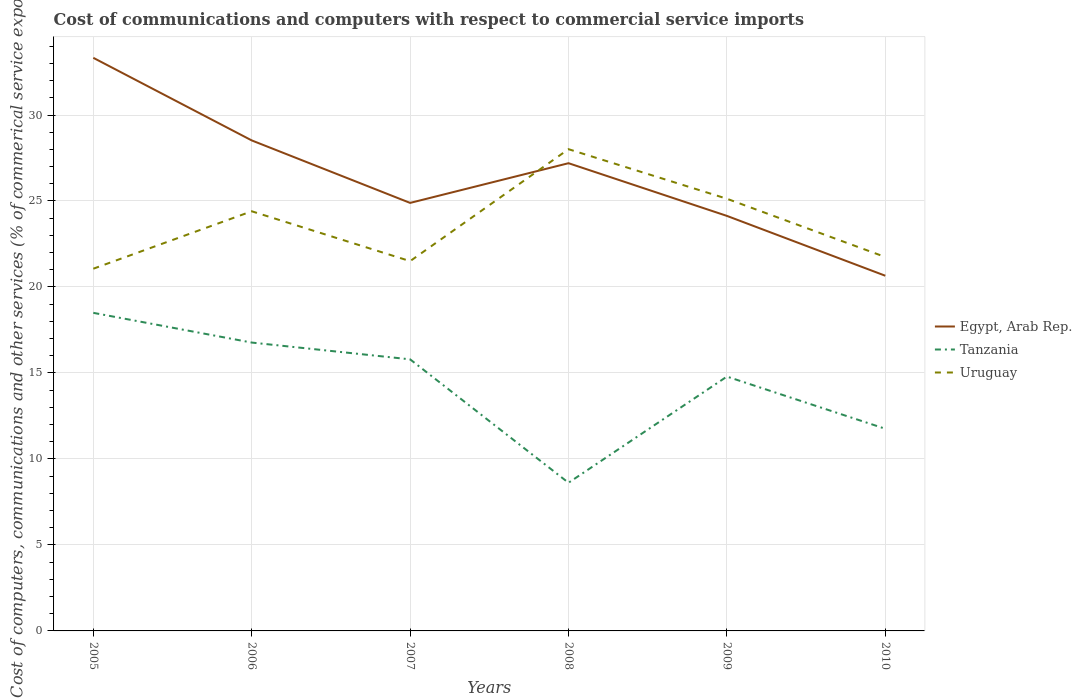How many different coloured lines are there?
Provide a short and direct response. 3. Does the line corresponding to Egypt, Arab Rep. intersect with the line corresponding to Uruguay?
Keep it short and to the point. Yes. Is the number of lines equal to the number of legend labels?
Offer a terse response. Yes. Across all years, what is the maximum cost of communications and computers in Tanzania?
Your answer should be very brief. 8.62. In which year was the cost of communications and computers in Egypt, Arab Rep. maximum?
Your answer should be very brief. 2010. What is the total cost of communications and computers in Tanzania in the graph?
Make the answer very short. 3.04. What is the difference between the highest and the second highest cost of communications and computers in Tanzania?
Offer a terse response. 9.88. What is the difference between the highest and the lowest cost of communications and computers in Egypt, Arab Rep.?
Your answer should be very brief. 3. Is the cost of communications and computers in Egypt, Arab Rep. strictly greater than the cost of communications and computers in Uruguay over the years?
Provide a succinct answer. No. Are the values on the major ticks of Y-axis written in scientific E-notation?
Keep it short and to the point. No. Does the graph contain any zero values?
Your response must be concise. No. How many legend labels are there?
Your response must be concise. 3. What is the title of the graph?
Your answer should be compact. Cost of communications and computers with respect to commercial service imports. What is the label or title of the Y-axis?
Keep it short and to the point. Cost of computers, communications and other services (% of commerical service exports). What is the Cost of computers, communications and other services (% of commerical service exports) in Egypt, Arab Rep. in 2005?
Give a very brief answer. 33.33. What is the Cost of computers, communications and other services (% of commerical service exports) of Tanzania in 2005?
Give a very brief answer. 18.5. What is the Cost of computers, communications and other services (% of commerical service exports) in Uruguay in 2005?
Offer a terse response. 21.06. What is the Cost of computers, communications and other services (% of commerical service exports) of Egypt, Arab Rep. in 2006?
Your answer should be compact. 28.52. What is the Cost of computers, communications and other services (% of commerical service exports) in Tanzania in 2006?
Keep it short and to the point. 16.77. What is the Cost of computers, communications and other services (% of commerical service exports) in Uruguay in 2006?
Keep it short and to the point. 24.4. What is the Cost of computers, communications and other services (% of commerical service exports) in Egypt, Arab Rep. in 2007?
Your answer should be compact. 24.89. What is the Cost of computers, communications and other services (% of commerical service exports) in Tanzania in 2007?
Ensure brevity in your answer.  15.79. What is the Cost of computers, communications and other services (% of commerical service exports) in Uruguay in 2007?
Offer a terse response. 21.5. What is the Cost of computers, communications and other services (% of commerical service exports) in Egypt, Arab Rep. in 2008?
Make the answer very short. 27.2. What is the Cost of computers, communications and other services (% of commerical service exports) in Tanzania in 2008?
Provide a succinct answer. 8.62. What is the Cost of computers, communications and other services (% of commerical service exports) in Uruguay in 2008?
Keep it short and to the point. 28.01. What is the Cost of computers, communications and other services (% of commerical service exports) in Egypt, Arab Rep. in 2009?
Your answer should be very brief. 24.13. What is the Cost of computers, communications and other services (% of commerical service exports) in Tanzania in 2009?
Keep it short and to the point. 14.79. What is the Cost of computers, communications and other services (% of commerical service exports) in Uruguay in 2009?
Your response must be concise. 25.13. What is the Cost of computers, communications and other services (% of commerical service exports) of Egypt, Arab Rep. in 2010?
Offer a very short reply. 20.65. What is the Cost of computers, communications and other services (% of commerical service exports) in Tanzania in 2010?
Give a very brief answer. 11.76. What is the Cost of computers, communications and other services (% of commerical service exports) of Uruguay in 2010?
Offer a terse response. 21.74. Across all years, what is the maximum Cost of computers, communications and other services (% of commerical service exports) of Egypt, Arab Rep.?
Ensure brevity in your answer.  33.33. Across all years, what is the maximum Cost of computers, communications and other services (% of commerical service exports) in Tanzania?
Your answer should be compact. 18.5. Across all years, what is the maximum Cost of computers, communications and other services (% of commerical service exports) in Uruguay?
Ensure brevity in your answer.  28.01. Across all years, what is the minimum Cost of computers, communications and other services (% of commerical service exports) of Egypt, Arab Rep.?
Offer a very short reply. 20.65. Across all years, what is the minimum Cost of computers, communications and other services (% of commerical service exports) of Tanzania?
Provide a succinct answer. 8.62. Across all years, what is the minimum Cost of computers, communications and other services (% of commerical service exports) in Uruguay?
Provide a succinct answer. 21.06. What is the total Cost of computers, communications and other services (% of commerical service exports) of Egypt, Arab Rep. in the graph?
Your response must be concise. 158.72. What is the total Cost of computers, communications and other services (% of commerical service exports) in Tanzania in the graph?
Your answer should be compact. 86.22. What is the total Cost of computers, communications and other services (% of commerical service exports) in Uruguay in the graph?
Provide a short and direct response. 141.85. What is the difference between the Cost of computers, communications and other services (% of commerical service exports) in Egypt, Arab Rep. in 2005 and that in 2006?
Offer a very short reply. 4.8. What is the difference between the Cost of computers, communications and other services (% of commerical service exports) of Tanzania in 2005 and that in 2006?
Keep it short and to the point. 1.73. What is the difference between the Cost of computers, communications and other services (% of commerical service exports) of Uruguay in 2005 and that in 2006?
Give a very brief answer. -3.34. What is the difference between the Cost of computers, communications and other services (% of commerical service exports) in Egypt, Arab Rep. in 2005 and that in 2007?
Offer a terse response. 8.44. What is the difference between the Cost of computers, communications and other services (% of commerical service exports) of Tanzania in 2005 and that in 2007?
Your response must be concise. 2.7. What is the difference between the Cost of computers, communications and other services (% of commerical service exports) in Uruguay in 2005 and that in 2007?
Your response must be concise. -0.44. What is the difference between the Cost of computers, communications and other services (% of commerical service exports) in Egypt, Arab Rep. in 2005 and that in 2008?
Give a very brief answer. 6.13. What is the difference between the Cost of computers, communications and other services (% of commerical service exports) of Tanzania in 2005 and that in 2008?
Your response must be concise. 9.88. What is the difference between the Cost of computers, communications and other services (% of commerical service exports) in Uruguay in 2005 and that in 2008?
Your response must be concise. -6.95. What is the difference between the Cost of computers, communications and other services (% of commerical service exports) of Egypt, Arab Rep. in 2005 and that in 2009?
Give a very brief answer. 9.19. What is the difference between the Cost of computers, communications and other services (% of commerical service exports) in Tanzania in 2005 and that in 2009?
Your answer should be compact. 3.71. What is the difference between the Cost of computers, communications and other services (% of commerical service exports) of Uruguay in 2005 and that in 2009?
Offer a very short reply. -4.07. What is the difference between the Cost of computers, communications and other services (% of commerical service exports) in Egypt, Arab Rep. in 2005 and that in 2010?
Your answer should be compact. 12.67. What is the difference between the Cost of computers, communications and other services (% of commerical service exports) in Tanzania in 2005 and that in 2010?
Your answer should be very brief. 6.74. What is the difference between the Cost of computers, communications and other services (% of commerical service exports) of Uruguay in 2005 and that in 2010?
Keep it short and to the point. -0.68. What is the difference between the Cost of computers, communications and other services (% of commerical service exports) in Egypt, Arab Rep. in 2006 and that in 2007?
Offer a terse response. 3.63. What is the difference between the Cost of computers, communications and other services (% of commerical service exports) in Tanzania in 2006 and that in 2007?
Give a very brief answer. 0.98. What is the difference between the Cost of computers, communications and other services (% of commerical service exports) of Uruguay in 2006 and that in 2007?
Your answer should be compact. 2.9. What is the difference between the Cost of computers, communications and other services (% of commerical service exports) in Egypt, Arab Rep. in 2006 and that in 2008?
Keep it short and to the point. 1.32. What is the difference between the Cost of computers, communications and other services (% of commerical service exports) in Tanzania in 2006 and that in 2008?
Your answer should be very brief. 8.15. What is the difference between the Cost of computers, communications and other services (% of commerical service exports) in Uruguay in 2006 and that in 2008?
Your answer should be very brief. -3.61. What is the difference between the Cost of computers, communications and other services (% of commerical service exports) of Egypt, Arab Rep. in 2006 and that in 2009?
Offer a very short reply. 4.39. What is the difference between the Cost of computers, communications and other services (% of commerical service exports) of Tanzania in 2006 and that in 2009?
Your answer should be very brief. 1.98. What is the difference between the Cost of computers, communications and other services (% of commerical service exports) of Uruguay in 2006 and that in 2009?
Your answer should be very brief. -0.73. What is the difference between the Cost of computers, communications and other services (% of commerical service exports) in Egypt, Arab Rep. in 2006 and that in 2010?
Make the answer very short. 7.87. What is the difference between the Cost of computers, communications and other services (% of commerical service exports) of Tanzania in 2006 and that in 2010?
Give a very brief answer. 5.01. What is the difference between the Cost of computers, communications and other services (% of commerical service exports) of Uruguay in 2006 and that in 2010?
Offer a terse response. 2.66. What is the difference between the Cost of computers, communications and other services (% of commerical service exports) in Egypt, Arab Rep. in 2007 and that in 2008?
Provide a short and direct response. -2.31. What is the difference between the Cost of computers, communications and other services (% of commerical service exports) of Tanzania in 2007 and that in 2008?
Keep it short and to the point. 7.18. What is the difference between the Cost of computers, communications and other services (% of commerical service exports) of Uruguay in 2007 and that in 2008?
Your response must be concise. -6.51. What is the difference between the Cost of computers, communications and other services (% of commerical service exports) in Egypt, Arab Rep. in 2007 and that in 2009?
Offer a terse response. 0.76. What is the difference between the Cost of computers, communications and other services (% of commerical service exports) in Uruguay in 2007 and that in 2009?
Give a very brief answer. -3.63. What is the difference between the Cost of computers, communications and other services (% of commerical service exports) of Egypt, Arab Rep. in 2007 and that in 2010?
Offer a very short reply. 4.24. What is the difference between the Cost of computers, communications and other services (% of commerical service exports) of Tanzania in 2007 and that in 2010?
Offer a very short reply. 4.04. What is the difference between the Cost of computers, communications and other services (% of commerical service exports) of Uruguay in 2007 and that in 2010?
Provide a short and direct response. -0.24. What is the difference between the Cost of computers, communications and other services (% of commerical service exports) of Egypt, Arab Rep. in 2008 and that in 2009?
Give a very brief answer. 3.06. What is the difference between the Cost of computers, communications and other services (% of commerical service exports) in Tanzania in 2008 and that in 2009?
Offer a terse response. -6.17. What is the difference between the Cost of computers, communications and other services (% of commerical service exports) in Uruguay in 2008 and that in 2009?
Make the answer very short. 2.88. What is the difference between the Cost of computers, communications and other services (% of commerical service exports) in Egypt, Arab Rep. in 2008 and that in 2010?
Offer a very short reply. 6.54. What is the difference between the Cost of computers, communications and other services (% of commerical service exports) of Tanzania in 2008 and that in 2010?
Ensure brevity in your answer.  -3.14. What is the difference between the Cost of computers, communications and other services (% of commerical service exports) in Uruguay in 2008 and that in 2010?
Provide a succinct answer. 6.27. What is the difference between the Cost of computers, communications and other services (% of commerical service exports) of Egypt, Arab Rep. in 2009 and that in 2010?
Give a very brief answer. 3.48. What is the difference between the Cost of computers, communications and other services (% of commerical service exports) in Tanzania in 2009 and that in 2010?
Keep it short and to the point. 3.04. What is the difference between the Cost of computers, communications and other services (% of commerical service exports) in Uruguay in 2009 and that in 2010?
Your answer should be very brief. 3.39. What is the difference between the Cost of computers, communications and other services (% of commerical service exports) in Egypt, Arab Rep. in 2005 and the Cost of computers, communications and other services (% of commerical service exports) in Tanzania in 2006?
Give a very brief answer. 16.56. What is the difference between the Cost of computers, communications and other services (% of commerical service exports) in Egypt, Arab Rep. in 2005 and the Cost of computers, communications and other services (% of commerical service exports) in Uruguay in 2006?
Provide a short and direct response. 8.92. What is the difference between the Cost of computers, communications and other services (% of commerical service exports) of Tanzania in 2005 and the Cost of computers, communications and other services (% of commerical service exports) of Uruguay in 2006?
Make the answer very short. -5.91. What is the difference between the Cost of computers, communications and other services (% of commerical service exports) in Egypt, Arab Rep. in 2005 and the Cost of computers, communications and other services (% of commerical service exports) in Tanzania in 2007?
Ensure brevity in your answer.  17.53. What is the difference between the Cost of computers, communications and other services (% of commerical service exports) in Egypt, Arab Rep. in 2005 and the Cost of computers, communications and other services (% of commerical service exports) in Uruguay in 2007?
Keep it short and to the point. 11.82. What is the difference between the Cost of computers, communications and other services (% of commerical service exports) of Tanzania in 2005 and the Cost of computers, communications and other services (% of commerical service exports) of Uruguay in 2007?
Keep it short and to the point. -3.01. What is the difference between the Cost of computers, communications and other services (% of commerical service exports) of Egypt, Arab Rep. in 2005 and the Cost of computers, communications and other services (% of commerical service exports) of Tanzania in 2008?
Offer a very short reply. 24.71. What is the difference between the Cost of computers, communications and other services (% of commerical service exports) of Egypt, Arab Rep. in 2005 and the Cost of computers, communications and other services (% of commerical service exports) of Uruguay in 2008?
Ensure brevity in your answer.  5.31. What is the difference between the Cost of computers, communications and other services (% of commerical service exports) in Tanzania in 2005 and the Cost of computers, communications and other services (% of commerical service exports) in Uruguay in 2008?
Ensure brevity in your answer.  -9.52. What is the difference between the Cost of computers, communications and other services (% of commerical service exports) of Egypt, Arab Rep. in 2005 and the Cost of computers, communications and other services (% of commerical service exports) of Tanzania in 2009?
Give a very brief answer. 18.54. What is the difference between the Cost of computers, communications and other services (% of commerical service exports) in Egypt, Arab Rep. in 2005 and the Cost of computers, communications and other services (% of commerical service exports) in Uruguay in 2009?
Offer a terse response. 8.19. What is the difference between the Cost of computers, communications and other services (% of commerical service exports) of Tanzania in 2005 and the Cost of computers, communications and other services (% of commerical service exports) of Uruguay in 2009?
Provide a short and direct response. -6.63. What is the difference between the Cost of computers, communications and other services (% of commerical service exports) of Egypt, Arab Rep. in 2005 and the Cost of computers, communications and other services (% of commerical service exports) of Tanzania in 2010?
Offer a terse response. 21.57. What is the difference between the Cost of computers, communications and other services (% of commerical service exports) of Egypt, Arab Rep. in 2005 and the Cost of computers, communications and other services (% of commerical service exports) of Uruguay in 2010?
Keep it short and to the point. 11.58. What is the difference between the Cost of computers, communications and other services (% of commerical service exports) in Tanzania in 2005 and the Cost of computers, communications and other services (% of commerical service exports) in Uruguay in 2010?
Offer a terse response. -3.25. What is the difference between the Cost of computers, communications and other services (% of commerical service exports) of Egypt, Arab Rep. in 2006 and the Cost of computers, communications and other services (% of commerical service exports) of Tanzania in 2007?
Offer a very short reply. 12.73. What is the difference between the Cost of computers, communications and other services (% of commerical service exports) of Egypt, Arab Rep. in 2006 and the Cost of computers, communications and other services (% of commerical service exports) of Uruguay in 2007?
Offer a very short reply. 7.02. What is the difference between the Cost of computers, communications and other services (% of commerical service exports) of Tanzania in 2006 and the Cost of computers, communications and other services (% of commerical service exports) of Uruguay in 2007?
Provide a short and direct response. -4.73. What is the difference between the Cost of computers, communications and other services (% of commerical service exports) of Egypt, Arab Rep. in 2006 and the Cost of computers, communications and other services (% of commerical service exports) of Tanzania in 2008?
Provide a succinct answer. 19.91. What is the difference between the Cost of computers, communications and other services (% of commerical service exports) of Egypt, Arab Rep. in 2006 and the Cost of computers, communications and other services (% of commerical service exports) of Uruguay in 2008?
Offer a very short reply. 0.51. What is the difference between the Cost of computers, communications and other services (% of commerical service exports) of Tanzania in 2006 and the Cost of computers, communications and other services (% of commerical service exports) of Uruguay in 2008?
Give a very brief answer. -11.24. What is the difference between the Cost of computers, communications and other services (% of commerical service exports) in Egypt, Arab Rep. in 2006 and the Cost of computers, communications and other services (% of commerical service exports) in Tanzania in 2009?
Your answer should be compact. 13.73. What is the difference between the Cost of computers, communications and other services (% of commerical service exports) of Egypt, Arab Rep. in 2006 and the Cost of computers, communications and other services (% of commerical service exports) of Uruguay in 2009?
Provide a short and direct response. 3.39. What is the difference between the Cost of computers, communications and other services (% of commerical service exports) of Tanzania in 2006 and the Cost of computers, communications and other services (% of commerical service exports) of Uruguay in 2009?
Ensure brevity in your answer.  -8.36. What is the difference between the Cost of computers, communications and other services (% of commerical service exports) in Egypt, Arab Rep. in 2006 and the Cost of computers, communications and other services (% of commerical service exports) in Tanzania in 2010?
Keep it short and to the point. 16.77. What is the difference between the Cost of computers, communications and other services (% of commerical service exports) of Egypt, Arab Rep. in 2006 and the Cost of computers, communications and other services (% of commerical service exports) of Uruguay in 2010?
Keep it short and to the point. 6.78. What is the difference between the Cost of computers, communications and other services (% of commerical service exports) of Tanzania in 2006 and the Cost of computers, communications and other services (% of commerical service exports) of Uruguay in 2010?
Give a very brief answer. -4.97. What is the difference between the Cost of computers, communications and other services (% of commerical service exports) in Egypt, Arab Rep. in 2007 and the Cost of computers, communications and other services (% of commerical service exports) in Tanzania in 2008?
Provide a succinct answer. 16.27. What is the difference between the Cost of computers, communications and other services (% of commerical service exports) in Egypt, Arab Rep. in 2007 and the Cost of computers, communications and other services (% of commerical service exports) in Uruguay in 2008?
Ensure brevity in your answer.  -3.12. What is the difference between the Cost of computers, communications and other services (% of commerical service exports) of Tanzania in 2007 and the Cost of computers, communications and other services (% of commerical service exports) of Uruguay in 2008?
Provide a short and direct response. -12.22. What is the difference between the Cost of computers, communications and other services (% of commerical service exports) in Egypt, Arab Rep. in 2007 and the Cost of computers, communications and other services (% of commerical service exports) in Tanzania in 2009?
Offer a terse response. 10.1. What is the difference between the Cost of computers, communications and other services (% of commerical service exports) in Egypt, Arab Rep. in 2007 and the Cost of computers, communications and other services (% of commerical service exports) in Uruguay in 2009?
Your response must be concise. -0.24. What is the difference between the Cost of computers, communications and other services (% of commerical service exports) in Tanzania in 2007 and the Cost of computers, communications and other services (% of commerical service exports) in Uruguay in 2009?
Ensure brevity in your answer.  -9.34. What is the difference between the Cost of computers, communications and other services (% of commerical service exports) in Egypt, Arab Rep. in 2007 and the Cost of computers, communications and other services (% of commerical service exports) in Tanzania in 2010?
Ensure brevity in your answer.  13.13. What is the difference between the Cost of computers, communications and other services (% of commerical service exports) in Egypt, Arab Rep. in 2007 and the Cost of computers, communications and other services (% of commerical service exports) in Uruguay in 2010?
Make the answer very short. 3.15. What is the difference between the Cost of computers, communications and other services (% of commerical service exports) in Tanzania in 2007 and the Cost of computers, communications and other services (% of commerical service exports) in Uruguay in 2010?
Your answer should be very brief. -5.95. What is the difference between the Cost of computers, communications and other services (% of commerical service exports) in Egypt, Arab Rep. in 2008 and the Cost of computers, communications and other services (% of commerical service exports) in Tanzania in 2009?
Your response must be concise. 12.41. What is the difference between the Cost of computers, communications and other services (% of commerical service exports) of Egypt, Arab Rep. in 2008 and the Cost of computers, communications and other services (% of commerical service exports) of Uruguay in 2009?
Ensure brevity in your answer.  2.07. What is the difference between the Cost of computers, communications and other services (% of commerical service exports) in Tanzania in 2008 and the Cost of computers, communications and other services (% of commerical service exports) in Uruguay in 2009?
Ensure brevity in your answer.  -16.51. What is the difference between the Cost of computers, communications and other services (% of commerical service exports) in Egypt, Arab Rep. in 2008 and the Cost of computers, communications and other services (% of commerical service exports) in Tanzania in 2010?
Make the answer very short. 15.44. What is the difference between the Cost of computers, communications and other services (% of commerical service exports) in Egypt, Arab Rep. in 2008 and the Cost of computers, communications and other services (% of commerical service exports) in Uruguay in 2010?
Keep it short and to the point. 5.46. What is the difference between the Cost of computers, communications and other services (% of commerical service exports) in Tanzania in 2008 and the Cost of computers, communications and other services (% of commerical service exports) in Uruguay in 2010?
Make the answer very short. -13.13. What is the difference between the Cost of computers, communications and other services (% of commerical service exports) in Egypt, Arab Rep. in 2009 and the Cost of computers, communications and other services (% of commerical service exports) in Tanzania in 2010?
Ensure brevity in your answer.  12.38. What is the difference between the Cost of computers, communications and other services (% of commerical service exports) in Egypt, Arab Rep. in 2009 and the Cost of computers, communications and other services (% of commerical service exports) in Uruguay in 2010?
Your answer should be very brief. 2.39. What is the difference between the Cost of computers, communications and other services (% of commerical service exports) in Tanzania in 2009 and the Cost of computers, communications and other services (% of commerical service exports) in Uruguay in 2010?
Make the answer very short. -6.95. What is the average Cost of computers, communications and other services (% of commerical service exports) in Egypt, Arab Rep. per year?
Give a very brief answer. 26.45. What is the average Cost of computers, communications and other services (% of commerical service exports) in Tanzania per year?
Your answer should be compact. 14.37. What is the average Cost of computers, communications and other services (% of commerical service exports) of Uruguay per year?
Keep it short and to the point. 23.64. In the year 2005, what is the difference between the Cost of computers, communications and other services (% of commerical service exports) in Egypt, Arab Rep. and Cost of computers, communications and other services (% of commerical service exports) in Tanzania?
Provide a short and direct response. 14.83. In the year 2005, what is the difference between the Cost of computers, communications and other services (% of commerical service exports) in Egypt, Arab Rep. and Cost of computers, communications and other services (% of commerical service exports) in Uruguay?
Your answer should be compact. 12.26. In the year 2005, what is the difference between the Cost of computers, communications and other services (% of commerical service exports) in Tanzania and Cost of computers, communications and other services (% of commerical service exports) in Uruguay?
Make the answer very short. -2.57. In the year 2006, what is the difference between the Cost of computers, communications and other services (% of commerical service exports) in Egypt, Arab Rep. and Cost of computers, communications and other services (% of commerical service exports) in Tanzania?
Provide a short and direct response. 11.75. In the year 2006, what is the difference between the Cost of computers, communications and other services (% of commerical service exports) of Egypt, Arab Rep. and Cost of computers, communications and other services (% of commerical service exports) of Uruguay?
Your response must be concise. 4.12. In the year 2006, what is the difference between the Cost of computers, communications and other services (% of commerical service exports) in Tanzania and Cost of computers, communications and other services (% of commerical service exports) in Uruguay?
Offer a very short reply. -7.63. In the year 2007, what is the difference between the Cost of computers, communications and other services (% of commerical service exports) of Egypt, Arab Rep. and Cost of computers, communications and other services (% of commerical service exports) of Tanzania?
Offer a very short reply. 9.1. In the year 2007, what is the difference between the Cost of computers, communications and other services (% of commerical service exports) in Egypt, Arab Rep. and Cost of computers, communications and other services (% of commerical service exports) in Uruguay?
Give a very brief answer. 3.39. In the year 2007, what is the difference between the Cost of computers, communications and other services (% of commerical service exports) in Tanzania and Cost of computers, communications and other services (% of commerical service exports) in Uruguay?
Provide a short and direct response. -5.71. In the year 2008, what is the difference between the Cost of computers, communications and other services (% of commerical service exports) in Egypt, Arab Rep. and Cost of computers, communications and other services (% of commerical service exports) in Tanzania?
Ensure brevity in your answer.  18.58. In the year 2008, what is the difference between the Cost of computers, communications and other services (% of commerical service exports) of Egypt, Arab Rep. and Cost of computers, communications and other services (% of commerical service exports) of Uruguay?
Ensure brevity in your answer.  -0.81. In the year 2008, what is the difference between the Cost of computers, communications and other services (% of commerical service exports) in Tanzania and Cost of computers, communications and other services (% of commerical service exports) in Uruguay?
Keep it short and to the point. -19.4. In the year 2009, what is the difference between the Cost of computers, communications and other services (% of commerical service exports) in Egypt, Arab Rep. and Cost of computers, communications and other services (% of commerical service exports) in Tanzania?
Your answer should be very brief. 9.34. In the year 2009, what is the difference between the Cost of computers, communications and other services (% of commerical service exports) of Egypt, Arab Rep. and Cost of computers, communications and other services (% of commerical service exports) of Uruguay?
Make the answer very short. -1. In the year 2009, what is the difference between the Cost of computers, communications and other services (% of commerical service exports) in Tanzania and Cost of computers, communications and other services (% of commerical service exports) in Uruguay?
Give a very brief answer. -10.34. In the year 2010, what is the difference between the Cost of computers, communications and other services (% of commerical service exports) of Egypt, Arab Rep. and Cost of computers, communications and other services (% of commerical service exports) of Tanzania?
Ensure brevity in your answer.  8.9. In the year 2010, what is the difference between the Cost of computers, communications and other services (% of commerical service exports) in Egypt, Arab Rep. and Cost of computers, communications and other services (% of commerical service exports) in Uruguay?
Your response must be concise. -1.09. In the year 2010, what is the difference between the Cost of computers, communications and other services (% of commerical service exports) of Tanzania and Cost of computers, communications and other services (% of commerical service exports) of Uruguay?
Keep it short and to the point. -9.99. What is the ratio of the Cost of computers, communications and other services (% of commerical service exports) in Egypt, Arab Rep. in 2005 to that in 2006?
Offer a very short reply. 1.17. What is the ratio of the Cost of computers, communications and other services (% of commerical service exports) of Tanzania in 2005 to that in 2006?
Offer a terse response. 1.1. What is the ratio of the Cost of computers, communications and other services (% of commerical service exports) of Uruguay in 2005 to that in 2006?
Offer a very short reply. 0.86. What is the ratio of the Cost of computers, communications and other services (% of commerical service exports) in Egypt, Arab Rep. in 2005 to that in 2007?
Ensure brevity in your answer.  1.34. What is the ratio of the Cost of computers, communications and other services (% of commerical service exports) of Tanzania in 2005 to that in 2007?
Provide a succinct answer. 1.17. What is the ratio of the Cost of computers, communications and other services (% of commerical service exports) of Uruguay in 2005 to that in 2007?
Provide a short and direct response. 0.98. What is the ratio of the Cost of computers, communications and other services (% of commerical service exports) of Egypt, Arab Rep. in 2005 to that in 2008?
Ensure brevity in your answer.  1.23. What is the ratio of the Cost of computers, communications and other services (% of commerical service exports) in Tanzania in 2005 to that in 2008?
Make the answer very short. 2.15. What is the ratio of the Cost of computers, communications and other services (% of commerical service exports) in Uruguay in 2005 to that in 2008?
Provide a succinct answer. 0.75. What is the ratio of the Cost of computers, communications and other services (% of commerical service exports) in Egypt, Arab Rep. in 2005 to that in 2009?
Your response must be concise. 1.38. What is the ratio of the Cost of computers, communications and other services (% of commerical service exports) of Tanzania in 2005 to that in 2009?
Your answer should be compact. 1.25. What is the ratio of the Cost of computers, communications and other services (% of commerical service exports) of Uruguay in 2005 to that in 2009?
Give a very brief answer. 0.84. What is the ratio of the Cost of computers, communications and other services (% of commerical service exports) in Egypt, Arab Rep. in 2005 to that in 2010?
Offer a terse response. 1.61. What is the ratio of the Cost of computers, communications and other services (% of commerical service exports) in Tanzania in 2005 to that in 2010?
Your answer should be compact. 1.57. What is the ratio of the Cost of computers, communications and other services (% of commerical service exports) in Uruguay in 2005 to that in 2010?
Offer a very short reply. 0.97. What is the ratio of the Cost of computers, communications and other services (% of commerical service exports) in Egypt, Arab Rep. in 2006 to that in 2007?
Offer a terse response. 1.15. What is the ratio of the Cost of computers, communications and other services (% of commerical service exports) of Tanzania in 2006 to that in 2007?
Provide a short and direct response. 1.06. What is the ratio of the Cost of computers, communications and other services (% of commerical service exports) in Uruguay in 2006 to that in 2007?
Your answer should be compact. 1.13. What is the ratio of the Cost of computers, communications and other services (% of commerical service exports) of Egypt, Arab Rep. in 2006 to that in 2008?
Ensure brevity in your answer.  1.05. What is the ratio of the Cost of computers, communications and other services (% of commerical service exports) in Tanzania in 2006 to that in 2008?
Offer a terse response. 1.95. What is the ratio of the Cost of computers, communications and other services (% of commerical service exports) in Uruguay in 2006 to that in 2008?
Offer a terse response. 0.87. What is the ratio of the Cost of computers, communications and other services (% of commerical service exports) of Egypt, Arab Rep. in 2006 to that in 2009?
Give a very brief answer. 1.18. What is the ratio of the Cost of computers, communications and other services (% of commerical service exports) of Tanzania in 2006 to that in 2009?
Give a very brief answer. 1.13. What is the ratio of the Cost of computers, communications and other services (% of commerical service exports) of Uruguay in 2006 to that in 2009?
Your answer should be very brief. 0.97. What is the ratio of the Cost of computers, communications and other services (% of commerical service exports) of Egypt, Arab Rep. in 2006 to that in 2010?
Keep it short and to the point. 1.38. What is the ratio of the Cost of computers, communications and other services (% of commerical service exports) of Tanzania in 2006 to that in 2010?
Keep it short and to the point. 1.43. What is the ratio of the Cost of computers, communications and other services (% of commerical service exports) of Uruguay in 2006 to that in 2010?
Provide a short and direct response. 1.12. What is the ratio of the Cost of computers, communications and other services (% of commerical service exports) in Egypt, Arab Rep. in 2007 to that in 2008?
Offer a very short reply. 0.92. What is the ratio of the Cost of computers, communications and other services (% of commerical service exports) of Tanzania in 2007 to that in 2008?
Your response must be concise. 1.83. What is the ratio of the Cost of computers, communications and other services (% of commerical service exports) of Uruguay in 2007 to that in 2008?
Offer a terse response. 0.77. What is the ratio of the Cost of computers, communications and other services (% of commerical service exports) in Egypt, Arab Rep. in 2007 to that in 2009?
Make the answer very short. 1.03. What is the ratio of the Cost of computers, communications and other services (% of commerical service exports) in Tanzania in 2007 to that in 2009?
Your answer should be very brief. 1.07. What is the ratio of the Cost of computers, communications and other services (% of commerical service exports) in Uruguay in 2007 to that in 2009?
Provide a short and direct response. 0.86. What is the ratio of the Cost of computers, communications and other services (% of commerical service exports) in Egypt, Arab Rep. in 2007 to that in 2010?
Your response must be concise. 1.21. What is the ratio of the Cost of computers, communications and other services (% of commerical service exports) in Tanzania in 2007 to that in 2010?
Give a very brief answer. 1.34. What is the ratio of the Cost of computers, communications and other services (% of commerical service exports) of Uruguay in 2007 to that in 2010?
Provide a short and direct response. 0.99. What is the ratio of the Cost of computers, communications and other services (% of commerical service exports) of Egypt, Arab Rep. in 2008 to that in 2009?
Offer a terse response. 1.13. What is the ratio of the Cost of computers, communications and other services (% of commerical service exports) of Tanzania in 2008 to that in 2009?
Keep it short and to the point. 0.58. What is the ratio of the Cost of computers, communications and other services (% of commerical service exports) of Uruguay in 2008 to that in 2009?
Your response must be concise. 1.11. What is the ratio of the Cost of computers, communications and other services (% of commerical service exports) of Egypt, Arab Rep. in 2008 to that in 2010?
Provide a short and direct response. 1.32. What is the ratio of the Cost of computers, communications and other services (% of commerical service exports) in Tanzania in 2008 to that in 2010?
Offer a very short reply. 0.73. What is the ratio of the Cost of computers, communications and other services (% of commerical service exports) in Uruguay in 2008 to that in 2010?
Keep it short and to the point. 1.29. What is the ratio of the Cost of computers, communications and other services (% of commerical service exports) in Egypt, Arab Rep. in 2009 to that in 2010?
Keep it short and to the point. 1.17. What is the ratio of the Cost of computers, communications and other services (% of commerical service exports) in Tanzania in 2009 to that in 2010?
Provide a succinct answer. 1.26. What is the ratio of the Cost of computers, communications and other services (% of commerical service exports) in Uruguay in 2009 to that in 2010?
Your answer should be compact. 1.16. What is the difference between the highest and the second highest Cost of computers, communications and other services (% of commerical service exports) in Egypt, Arab Rep.?
Ensure brevity in your answer.  4.8. What is the difference between the highest and the second highest Cost of computers, communications and other services (% of commerical service exports) in Tanzania?
Provide a short and direct response. 1.73. What is the difference between the highest and the second highest Cost of computers, communications and other services (% of commerical service exports) in Uruguay?
Make the answer very short. 2.88. What is the difference between the highest and the lowest Cost of computers, communications and other services (% of commerical service exports) in Egypt, Arab Rep.?
Keep it short and to the point. 12.67. What is the difference between the highest and the lowest Cost of computers, communications and other services (% of commerical service exports) of Tanzania?
Provide a short and direct response. 9.88. What is the difference between the highest and the lowest Cost of computers, communications and other services (% of commerical service exports) in Uruguay?
Provide a succinct answer. 6.95. 